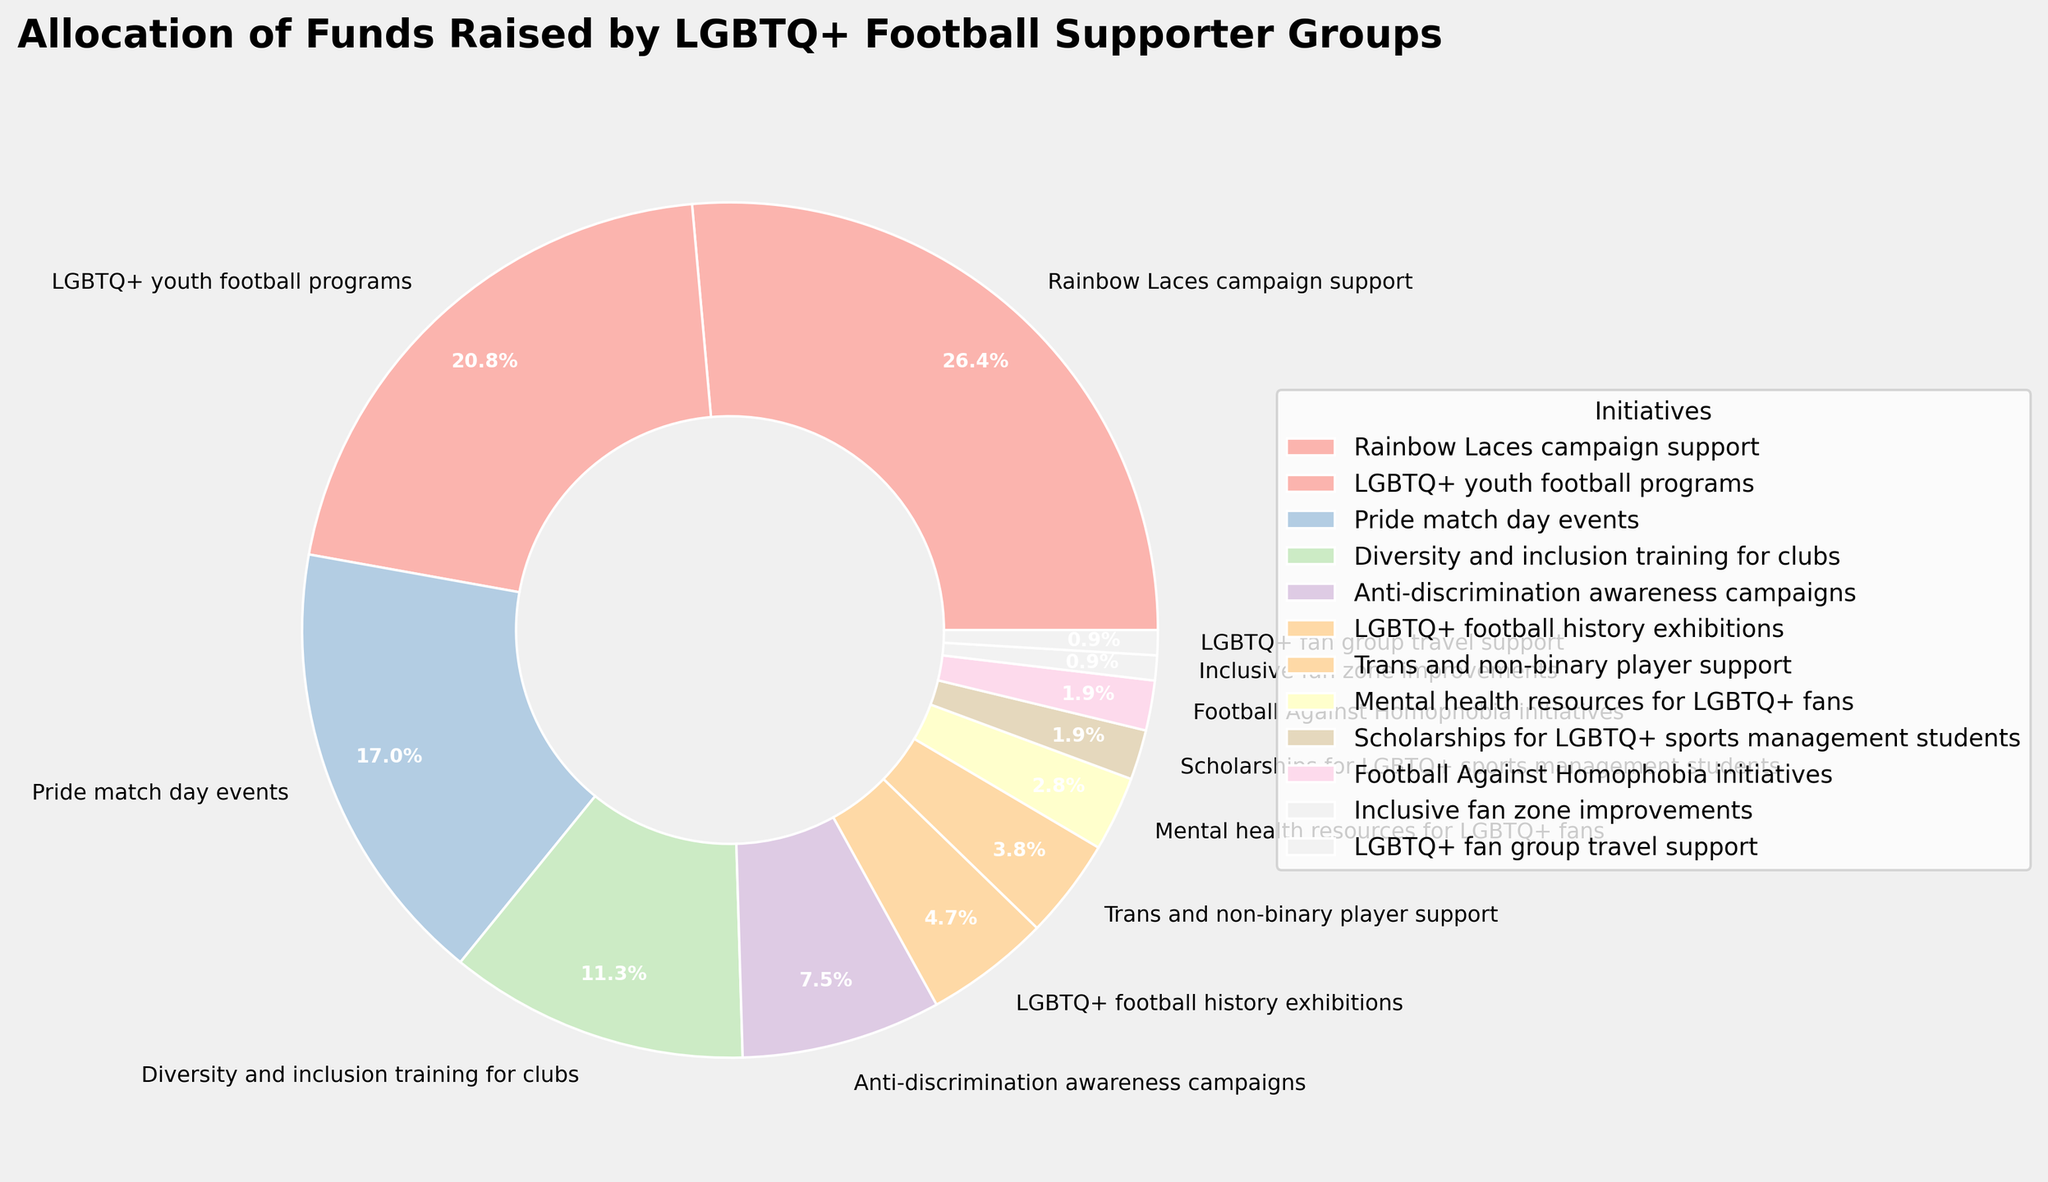Which initiative receives the highest percentage of funds? The pie chart shows the allocation of funds; the largest section corresponds to the Rainbow Laces campaign support at 28%.
Answer: Rainbow Laces campaign support How does the percentage allocated to LGBTQ+ youth football programs compare to Pride match day events? The chart indicates 22% for LGBTQ+ youth football programs and 18% for Pride match day events. 22% is greater than 18%.
Answer: LGBTQ+ youth football programs receive 4% more funds What total percentage of funds goes to anti-discrimination awareness campaigns and LGBTQ+ football history exhibitions? From the pie chart, 8% is allocated to anti-discrimination awareness campaigns and 5% to LGBTQ+ football history exhibitions, resulting in a total of 8% + 5% = 13%.
Answer: 13% Which initiatives receive the least amount of funding, and what is their combined percentage? The smallest percentages are for Inclusive fan zone improvements and LGBTQ+ fan group travel support, each at 1%. Combined, they amount to 1% + 1% = 2%.
Answer: Inclusive fan zone improvements and LGBTQ+ fan group travel support; 2% Among mental health resources for LGBTQ+ fans, trans and non-binary player support, and diversity and inclusion training for clubs, which initiative has the highest percentage allocation? The chart shows 3% for mental health resources, 4% for trans and non-binary player support, and 12% for diversity and inclusion training for clubs. The highest percentage is for diversity and inclusion training for clubs.
Answer: Diversity and inclusion training for clubs What percentage of funds is allocated to initiatives specifically targeting direct player support (including trans and non-binary player support and LGBTQ+ youth football programs)? From the chart, 22% is for LGBTQ+ youth football programs and 4% for trans and non-binary player support, totaling to 22% + 4% = 26%.
Answer: 26% What is the percentage difference between the funds allocated to Rainbow Laces campaign support and LGBTQ+ fan group travel support? Rainbow Laces campaign support receives 28%, while LGBTQ+ fan group travel support receives 1%, resulting in a difference of 28% - 1% = 27%.
Answer: 27% Do anti-discrimination awareness campaigns receive more funding than mental health resources for LGBTQ+ fans? The pie chart shows 8% for anti-discrimination awareness campaigns and 3% for mental health resources, so anti-discrimination awareness campaigns receive more funding.
Answer: Yes What initiatives together account for 40% of the funds allocation? Adding the percentages on the pie chart, Rainbow Laces campaign support (28%) and LGBTQ+ youth football programs (22%) sum to 50%, but to get exactly 40%, we can combine Rainbow Laces campaign support (28%) and Pride match day events (18%), summing to 28% + 18% = 46%, so we combine Diversity and inclusion training for clubs (12%) with Rainbow Laces campaign support (28%), resulting in 40%.
Answer: Rainbow Laces campaign support and Diversity and inclusion training for clubs 